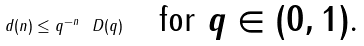Convert formula to latex. <formula><loc_0><loc_0><loc_500><loc_500>d ( n ) \leq q ^ { - n } \ D ( q ) \quad \text {for $q \in (0,1)$.}</formula> 